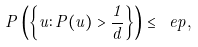Convert formula to latex. <formula><loc_0><loc_0><loc_500><loc_500>P \left ( \left \{ u \colon P ( u ) > \frac { 1 } { d } \right \} \right ) \leq \ e p ,</formula> 